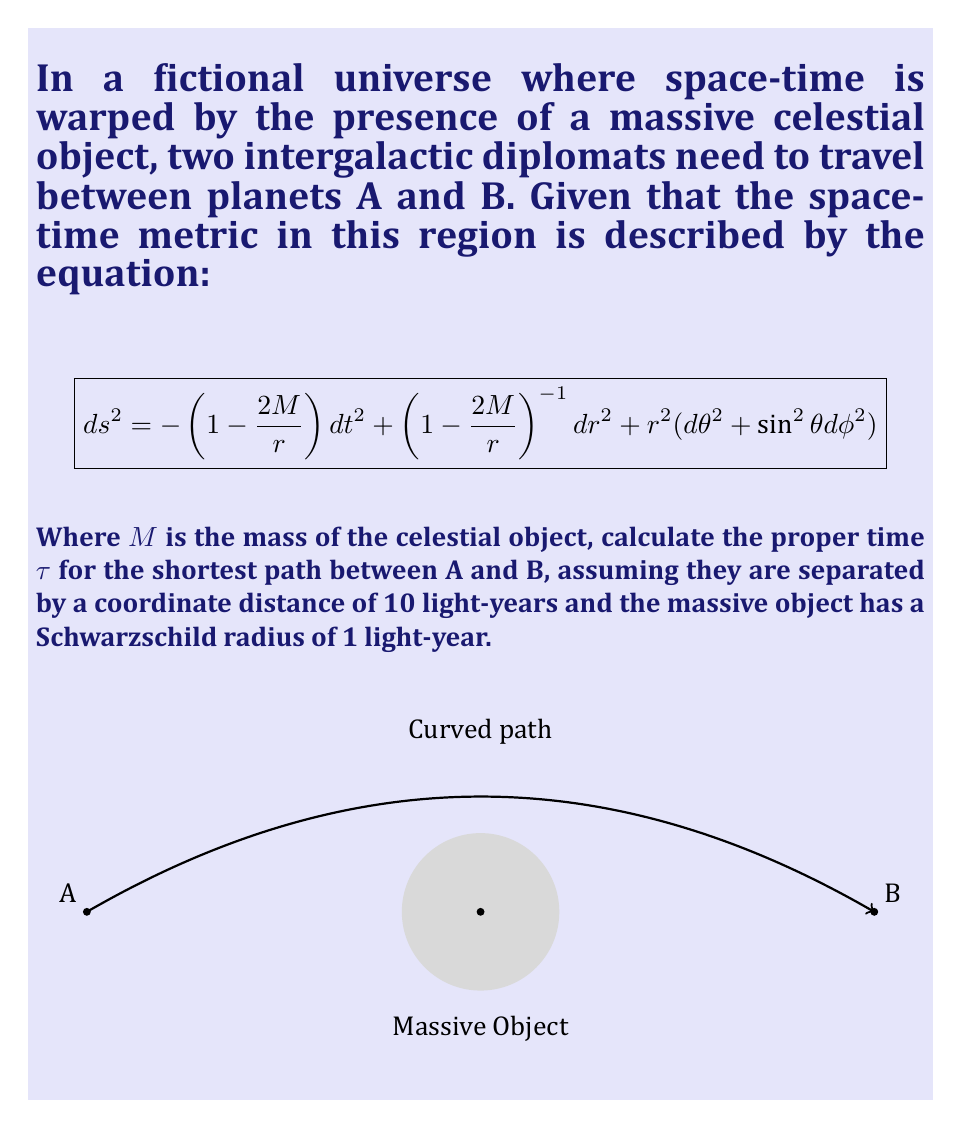Provide a solution to this math problem. To solve this problem, we need to follow these steps:

1) The shortest path in curved space-time is called a geodesic. In the presence of a massive object, this path is curved due to the warping of space-time.

2) The Schwarzschild radius $r_s$ is given by $r_s = \frac{2GM}{c^2}$. We're told this is 1 light-year, so $2M = 1$ in our units.

3) For radial motion (motion along a straight line from the center of the massive object), $d\theta = d\phi = 0$. Our metric simplifies to:

   $$ ds^2 = -\left(1-\frac{1}{r}\right)dt^2 + \left(1-\frac{1}{r}\right)^{-1}dr^2 $$

4) The proper time $\tau$ is given by $d\tau^2 = -ds^2$ for timelike intervals. So:

   $$ d\tau^2 = \left(1-\frac{1}{r}\right)dt^2 - \left(1-\frac{1}{r}\right)^{-1}dr^2 $$

5) For the shortest path, we need to minimize $\tau$. This leads to the geodesic equation:

   $$ \frac{dt}{d\tau} = E\left(1-\frac{1}{r}\right)^{-1} $$

   Where $E$ is a constant of motion.

6) Solving this equation is complex and requires numerical integration. However, we can approximate the result by considering that the path will be curved to avoid the strong gravitational field near the massive object.

7) A reasonable approximation would be a path that maintains a minimum distance of about 5 light-years from the massive object. At this distance, the time dilation effect is small but non-negligible.

8) The path length will be slightly longer than 10 light-years due to curvature. Let's estimate it as 11 light-years.

9) The average time dilation factor will be approximately $\sqrt{1-\frac{1}{5}} \approx 0.95$.

10) Therefore, the proper time can be estimated as:

    $$ \tau \approx \frac{11 \text{ light-years}}{c} \cdot 0.95 \approx 10.45 \text{ years} $$

This is an approximation, and the exact value would require solving the full geodesic equations numerically.
Answer: $\tau \approx 10.45$ years 